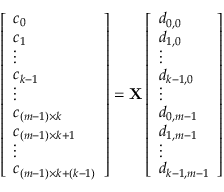Convert formula to latex. <formula><loc_0><loc_0><loc_500><loc_500>\begin{array} { r } { \left [ \begin{array} { l } { c _ { 0 } } \\ { c _ { 1 } } \\ { \vdots } \\ { c _ { k - 1 } } \\ { \vdots } \\ { c _ { ( m - 1 ) \times k } } \\ { c _ { ( m - 1 ) \times k + 1 } } \\ { \vdots } \\ { c _ { ( m - 1 ) \times k + ( k - 1 ) } } \end{array} \right ] = { X } \left [ \begin{array} { l } { d _ { 0 , 0 } } \\ { d _ { 1 , 0 } } \\ { \vdots } \\ { d _ { k - 1 , 0 } } \\ { \vdots } \\ { d _ { 0 , m - 1 } } \\ { d _ { 1 , m - 1 } } \\ { \vdots } \\ { d _ { k - 1 , m - 1 } } \end{array} \right ] } \end{array}</formula> 